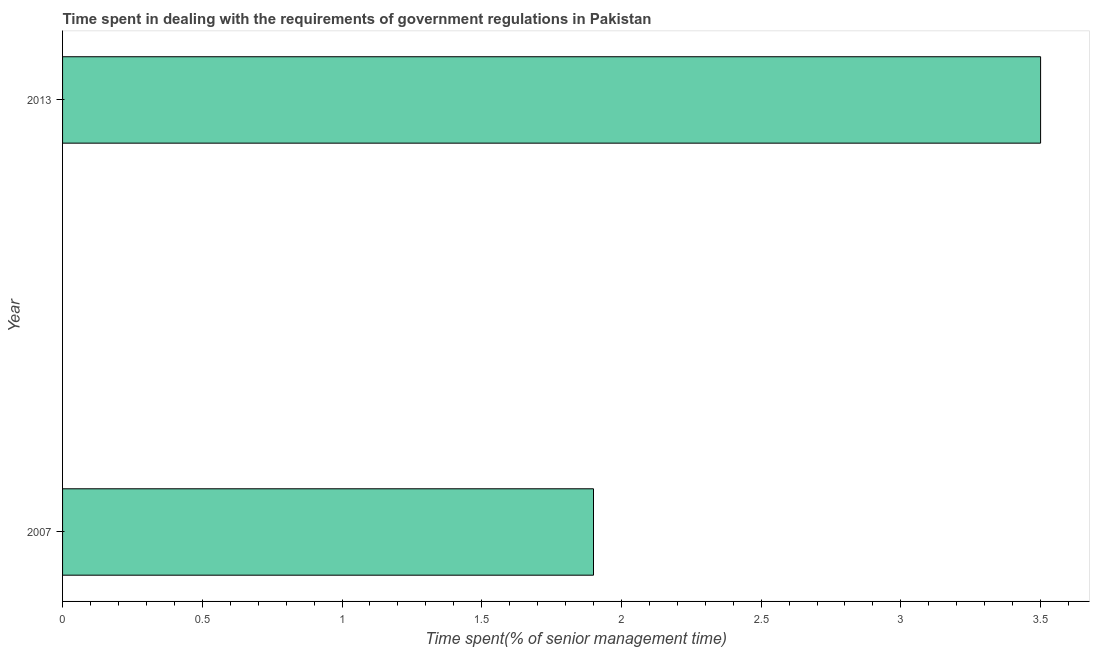Does the graph contain any zero values?
Your answer should be very brief. No. Does the graph contain grids?
Ensure brevity in your answer.  No. What is the title of the graph?
Make the answer very short. Time spent in dealing with the requirements of government regulations in Pakistan. What is the label or title of the X-axis?
Keep it short and to the point. Time spent(% of senior management time). What is the time spent in dealing with government regulations in 2013?
Provide a succinct answer. 3.5. In which year was the time spent in dealing with government regulations maximum?
Provide a short and direct response. 2013. In which year was the time spent in dealing with government regulations minimum?
Offer a very short reply. 2007. What is the average time spent in dealing with government regulations per year?
Ensure brevity in your answer.  2.7. What is the median time spent in dealing with government regulations?
Your answer should be compact. 2.7. Do a majority of the years between 2007 and 2013 (inclusive) have time spent in dealing with government regulations greater than 3.5 %?
Give a very brief answer. No. What is the ratio of the time spent in dealing with government regulations in 2007 to that in 2013?
Your answer should be very brief. 0.54. How many bars are there?
Give a very brief answer. 2. Are the values on the major ticks of X-axis written in scientific E-notation?
Make the answer very short. No. What is the ratio of the Time spent(% of senior management time) in 2007 to that in 2013?
Ensure brevity in your answer.  0.54. 